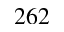Convert formula to latex. <formula><loc_0><loc_0><loc_500><loc_500>2 6 2</formula> 